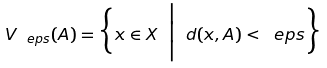<formula> <loc_0><loc_0><loc_500><loc_500>V _ { \ e p s } ( A ) = \Big \{ x \in X \ \Big | \ d ( x , A ) < \ e p s \Big \}</formula> 